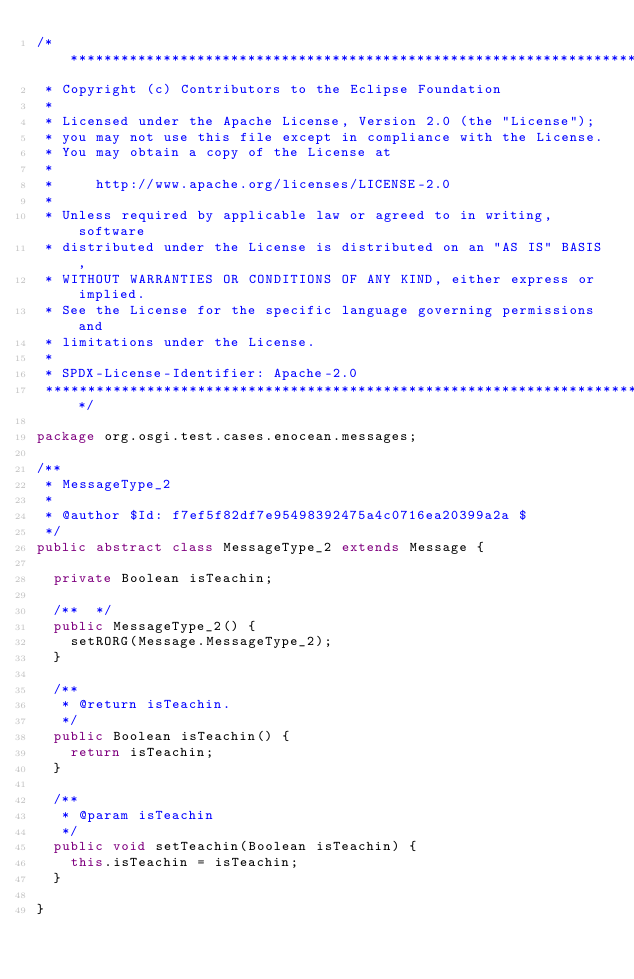<code> <loc_0><loc_0><loc_500><loc_500><_Java_>/*******************************************************************************
 * Copyright (c) Contributors to the Eclipse Foundation
 *
 * Licensed under the Apache License, Version 2.0 (the "License");
 * you may not use this file except in compliance with the License.
 * You may obtain a copy of the License at
 *
 *     http://www.apache.org/licenses/LICENSE-2.0
 *
 * Unless required by applicable law or agreed to in writing, software
 * distributed under the License is distributed on an "AS IS" BASIS,
 * WITHOUT WARRANTIES OR CONDITIONS OF ANY KIND, either express or implied.
 * See the License for the specific language governing permissions and
 * limitations under the License.
 *
 * SPDX-License-Identifier: Apache-2.0 
 *******************************************************************************/

package org.osgi.test.cases.enocean.messages;

/**
 * MessageType_2
 * 
 * @author $Id: f7ef5f82df7e95498392475a4c0716ea20399a2a $
 */
public abstract class MessageType_2 extends Message {

	private Boolean	isTeachin;

	/**  */
	public MessageType_2() {
		setRORG(Message.MessageType_2);
	}

	/**
	 * @return isTeachin.
	 */
	public Boolean isTeachin() {
		return isTeachin;
	}

	/**
	 * @param isTeachin
	 */
	public void setTeachin(Boolean isTeachin) {
		this.isTeachin = isTeachin;
	}

}
</code> 